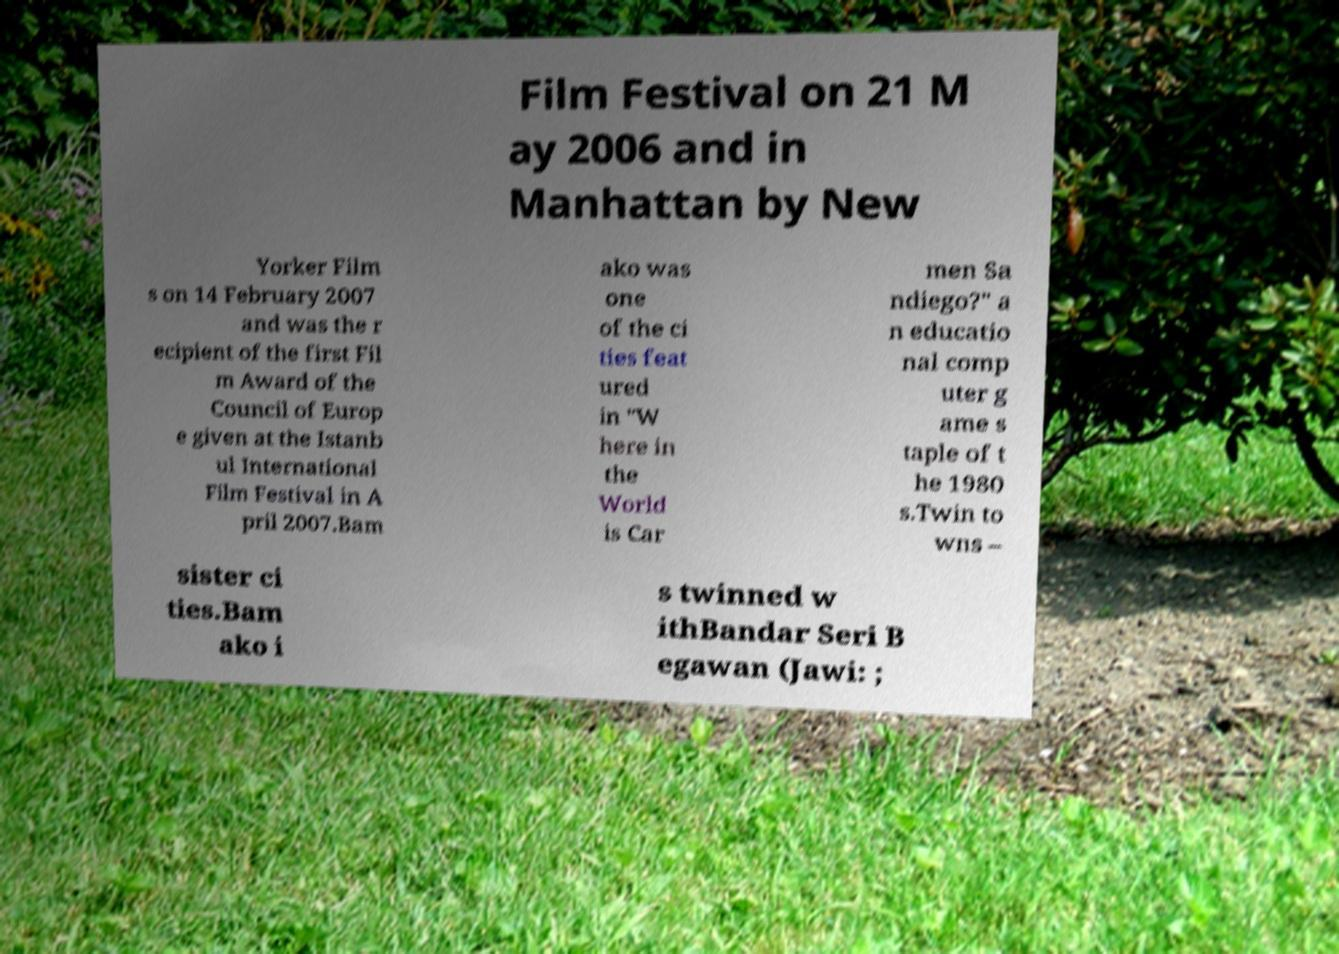Please read and relay the text visible in this image. What does it say? Film Festival on 21 M ay 2006 and in Manhattan by New Yorker Film s on 14 February 2007 and was the r ecipient of the first Fil m Award of the Council of Europ e given at the Istanb ul International Film Festival in A pril 2007.Bam ako was one of the ci ties feat ured in "W here in the World is Car men Sa ndiego?" a n educatio nal comp uter g ame s taple of t he 1980 s.Twin to wns – sister ci ties.Bam ako i s twinned w ithBandar Seri B egawan (Jawi: ; 